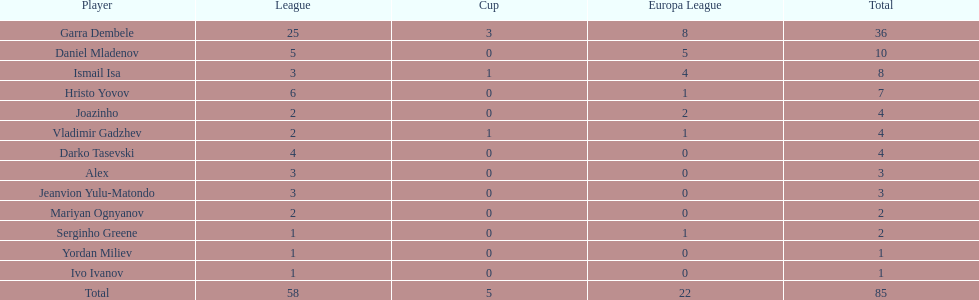How many players had a total of 4? 3. Could you help me parse every detail presented in this table? {'header': ['Player', 'League', 'Cup', 'Europa League', 'Total'], 'rows': [['Garra Dembele', '25', '3', '8', '36'], ['Daniel Mladenov', '5', '0', '5', '10'], ['Ismail Isa', '3', '1', '4', '8'], ['Hristo Yovov', '6', '0', '1', '7'], ['Joazinho', '2', '0', '2', '4'], ['Vladimir Gadzhev', '2', '1', '1', '4'], ['Darko Tasevski', '4', '0', '0', '4'], ['Alex', '3', '0', '0', '3'], ['Jeanvion Yulu-Matondo', '3', '0', '0', '3'], ['Mariyan Ognyanov', '2', '0', '0', '2'], ['Serginho Greene', '1', '0', '1', '2'], ['Yordan Miliev', '1', '0', '0', '1'], ['Ivo Ivanov', '1', '0', '0', '1'], ['Total', '58', '5', '22', '85']]} 